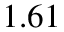Convert formula to latex. <formula><loc_0><loc_0><loc_500><loc_500>1 . 6 1</formula> 